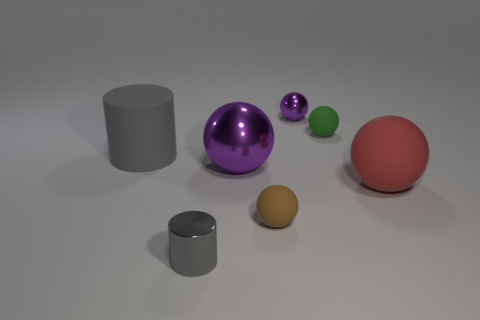Subtract all metal spheres. How many spheres are left? 3 Subtract all brown spheres. How many spheres are left? 4 Subtract all spheres. How many objects are left? 2 Add 1 purple balls. How many objects exist? 8 Subtract 3 balls. How many balls are left? 2 Add 6 big purple metal spheres. How many big purple metal spheres are left? 7 Add 5 large brown metal objects. How many large brown metal objects exist? 5 Subtract 0 red cylinders. How many objects are left? 7 Subtract all blue balls. Subtract all red cylinders. How many balls are left? 5 Subtract all purple cylinders. How many blue balls are left? 0 